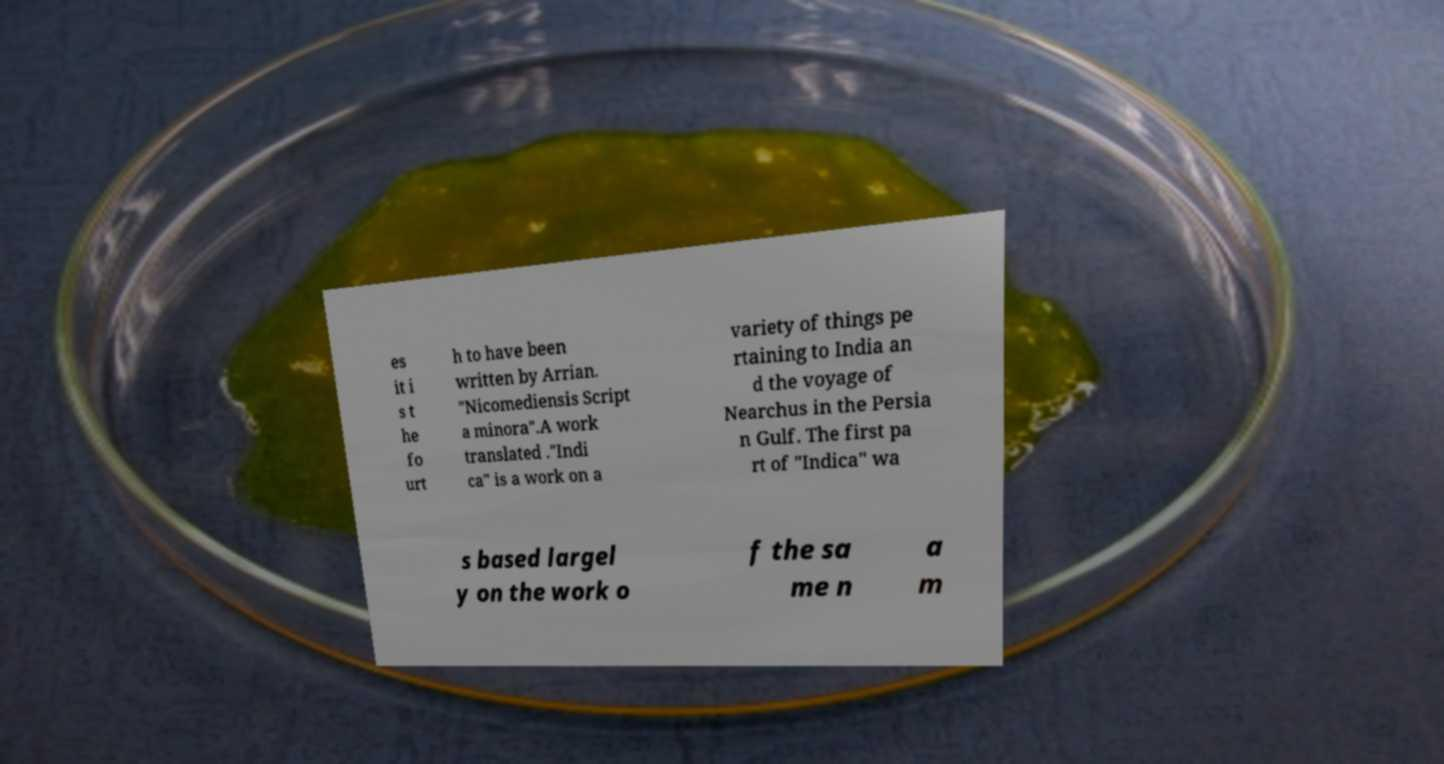I need the written content from this picture converted into text. Can you do that? es it i s t he fo urt h to have been written by Arrian. "Nicomediensis Script a minora".A work translated ."Indi ca" is a work on a variety of things pe rtaining to India an d the voyage of Nearchus in the Persia n Gulf. The first pa rt of "Indica" wa s based largel y on the work o f the sa me n a m 